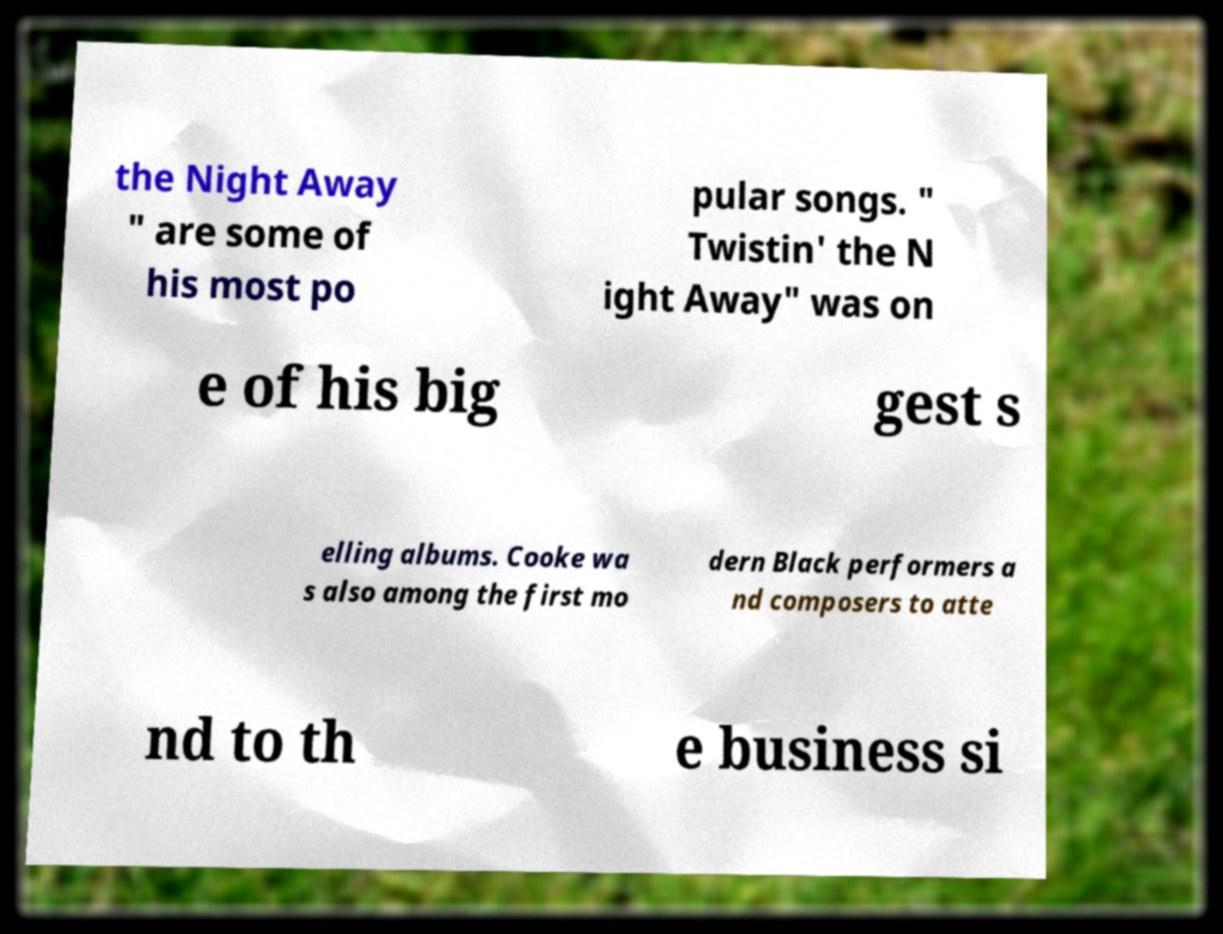Could you extract and type out the text from this image? the Night Away " are some of his most po pular songs. " Twistin' the N ight Away" was on e of his big gest s elling albums. Cooke wa s also among the first mo dern Black performers a nd composers to atte nd to th e business si 